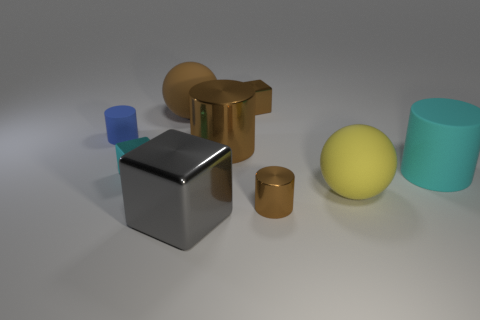Subtract all blue cubes. Subtract all cyan spheres. How many cubes are left? 3 Add 1 large yellow spheres. How many objects exist? 10 Subtract all spheres. How many objects are left? 7 Add 1 large metallic blocks. How many large metallic blocks exist? 2 Subtract 1 blue cylinders. How many objects are left? 8 Subtract all tiny blue objects. Subtract all small cylinders. How many objects are left? 6 Add 3 big gray cubes. How many big gray cubes are left? 4 